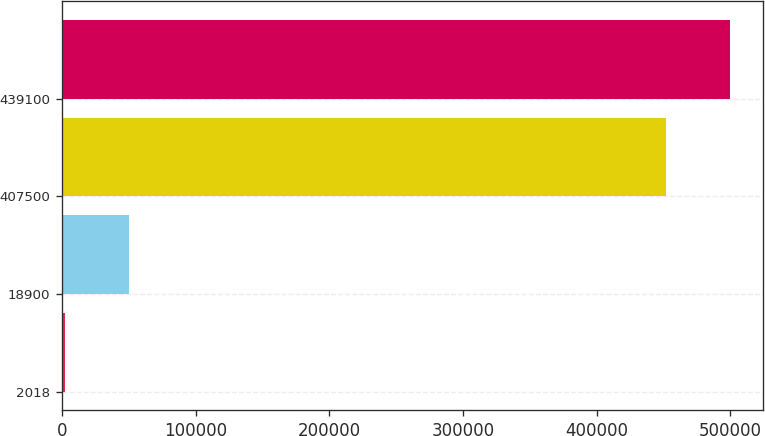Convert chart. <chart><loc_0><loc_0><loc_500><loc_500><bar_chart><fcel>2018<fcel>18900<fcel>407500<fcel>439100<nl><fcel>2016<fcel>49731.1<fcel>451750<fcel>499465<nl></chart> 